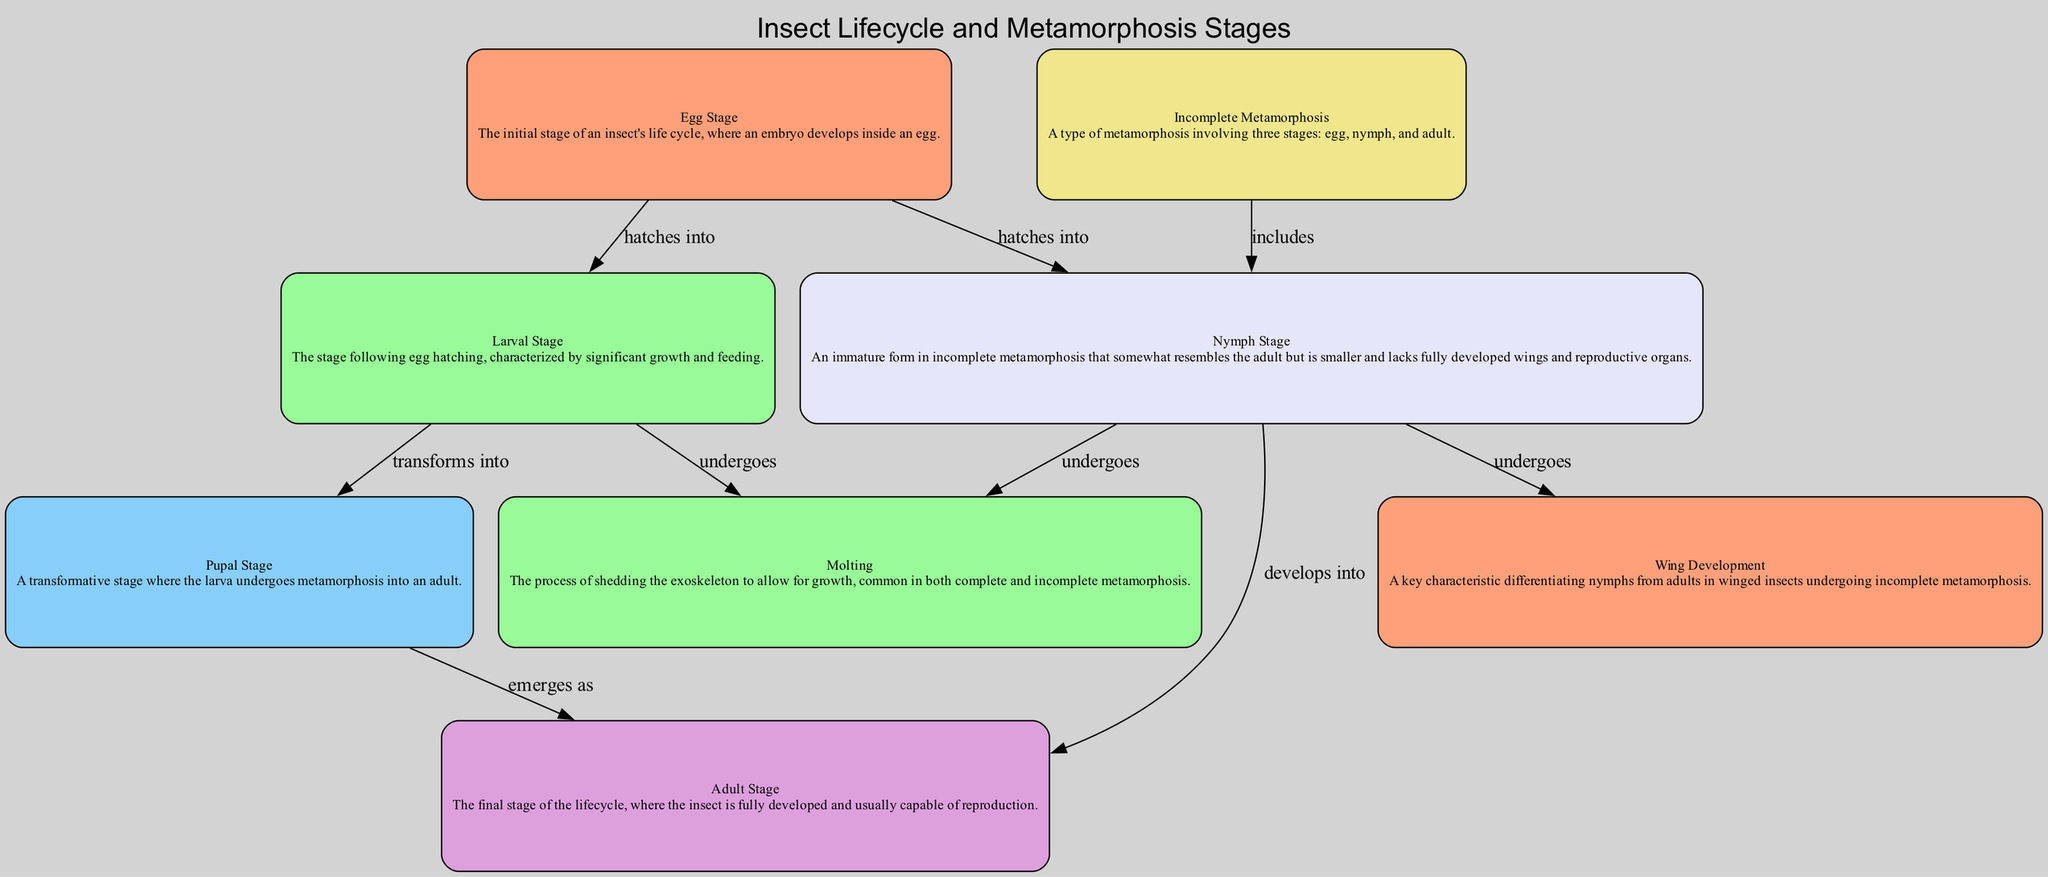What is the first stage of the insect lifecycle? The diagram states that the initial stage of an insect's lifecycle is the Egg Stage, which is the starting point for all other stages.
Answer: Egg Stage How many stages are involved in complete metamorphosis? The diagram outlines four stages that consist of Egg, Larval, Pupal, and Adult stages, hence it includes a total of four distinct stages.
Answer: Four Which stage undergoes molting? The diagram indicates that both the Larval Stage and Nymph Stage undergo molting as they grow, highlighting a critical process for both stages.
Answer: Larval Stage, Nymph Stage What stage immediately follows the egg hatching in complete metamorphosis? According to the diagram, the stage that follows after the egg hatching is the Larval Stage, which is characterized by feeding and growth.
Answer: Larval Stage In the incomplete metamorphosis, what is the second stage? The flow in the diagram illustrates that after the Egg Stage in incomplete metamorphosis, the Nymph Stage follows, which develops into the Adult Stage.
Answer: Nymph Stage How does the Nymph Stage differ from the Adult Stage? The diagram explains that the Nymph Stage resembles the Adult but is smaller and lacks fully developed wings and reproductive organs, making it an immature form.
Answer: Smaller, lacks wings What do nymphs undergo that leads to the development of wings? The diagram specifies that during their growth, Nymphs undergo Wing Development through progressive molts, marking their transition into more mature forms.
Answer: Wing Development What is the relationship between the Larval Stage and the Pupal Stage? The diagram points out that the Larval Stage transforms into the Pupal Stage, indicating a metamorphic progression toward adulthood.
Answer: Transforms into What process is common to both complete and incomplete metamorphosis? The diagram highlights that Molting is a common process necessary for growth in both complete and incomplete metamorphosis, serving as a vital aspect of insect development.
Answer: Molting 